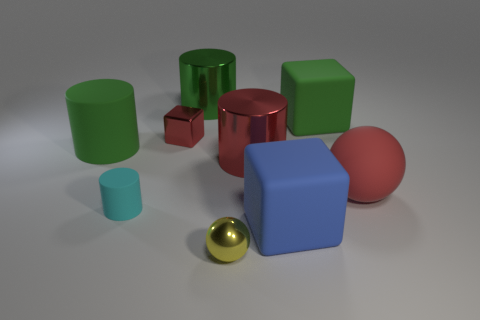There is a big green thing that is right of the yellow metallic thing; what is its material?
Offer a very short reply. Rubber. What color is the metallic block?
Provide a succinct answer. Red. There is a red shiny object to the left of the small yellow object; is it the same size as the rubber cylinder behind the big red ball?
Offer a terse response. No. There is a green thing that is both to the left of the metallic sphere and in front of the green metal cylinder; what is its size?
Your response must be concise. Large. There is another large matte thing that is the same shape as the cyan thing; what is its color?
Keep it short and to the point. Green. Is the number of big blue objects that are on the right side of the blue cube greater than the number of large green rubber cylinders to the right of the small cyan cylinder?
Offer a terse response. No. How many other things are there of the same shape as the big blue matte object?
Your response must be concise. 2. There is a large blue object to the right of the red cylinder; is there a big matte object that is on the left side of it?
Provide a succinct answer. Yes. What number of tiny yellow rubber balls are there?
Your answer should be compact. 0. There is a tiny metallic cube; is its color the same as the small object that is to the right of the large green shiny object?
Offer a very short reply. No. 